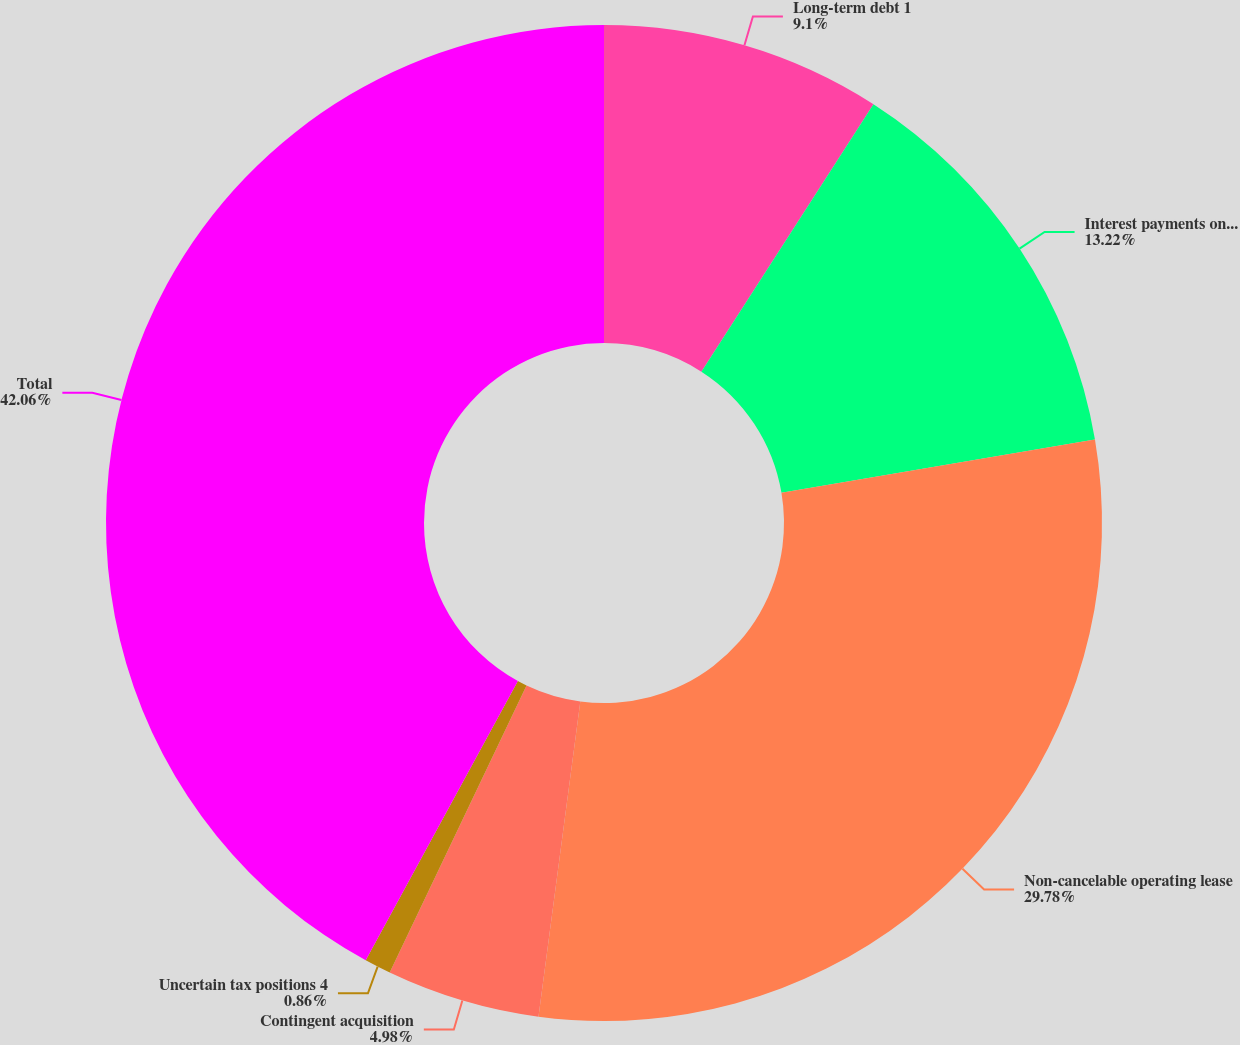<chart> <loc_0><loc_0><loc_500><loc_500><pie_chart><fcel>Long-term debt 1<fcel>Interest payments on long-term<fcel>Non-cancelable operating lease<fcel>Contingent acquisition<fcel>Uncertain tax positions 4<fcel>Total<nl><fcel>9.1%<fcel>13.22%<fcel>29.78%<fcel>4.98%<fcel>0.86%<fcel>42.06%<nl></chart> 